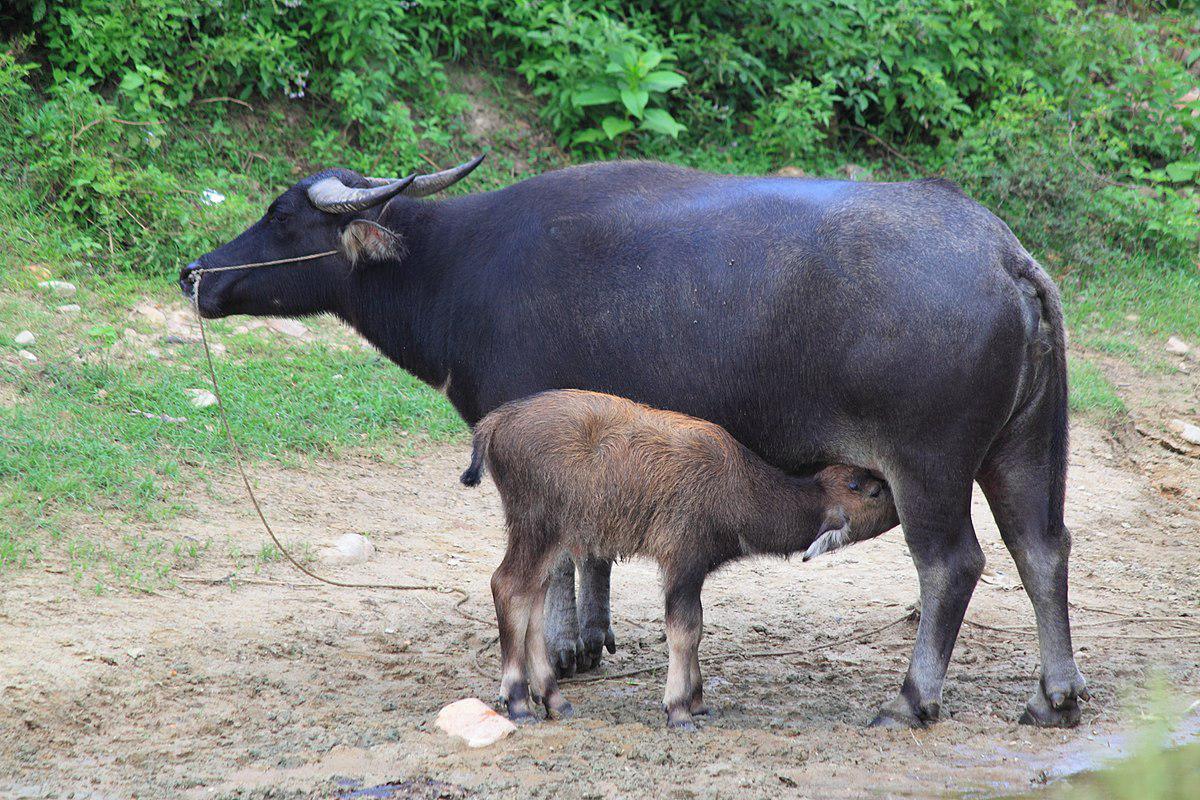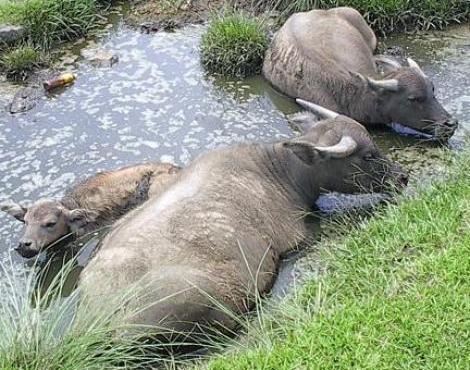The first image is the image on the left, the second image is the image on the right. For the images shown, is this caption "In at least one image the oxen is partially submerged, past the legs, in water." true? Answer yes or no. Yes. 